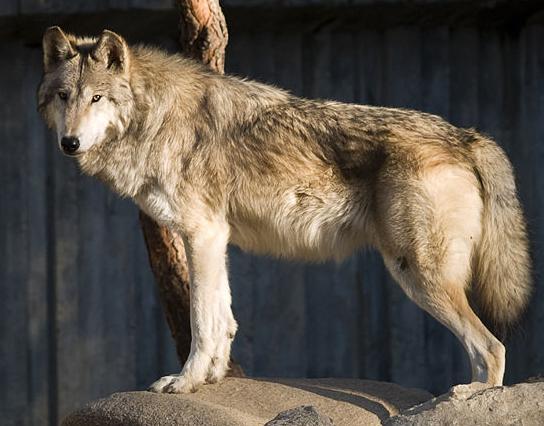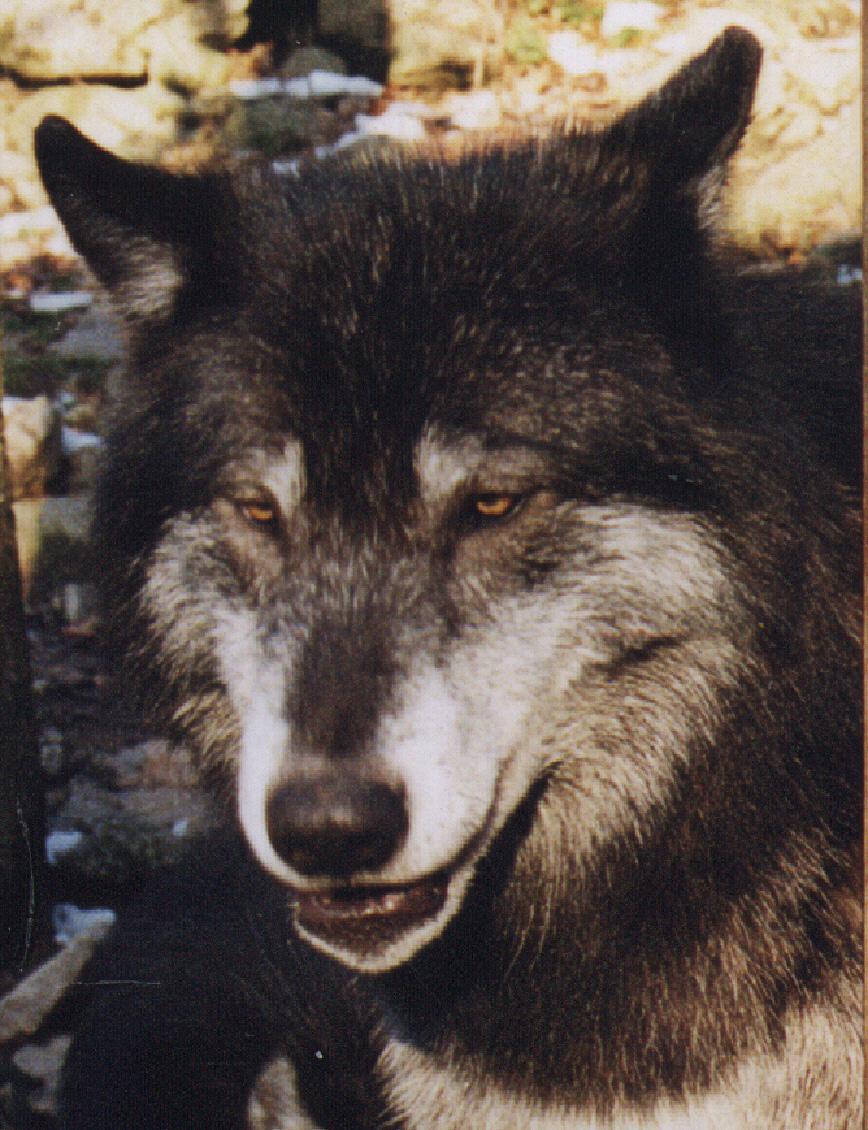The first image is the image on the left, the second image is the image on the right. Given the left and right images, does the statement "One of the dogs is black with a white muzzle." hold true? Answer yes or no. Yes. 